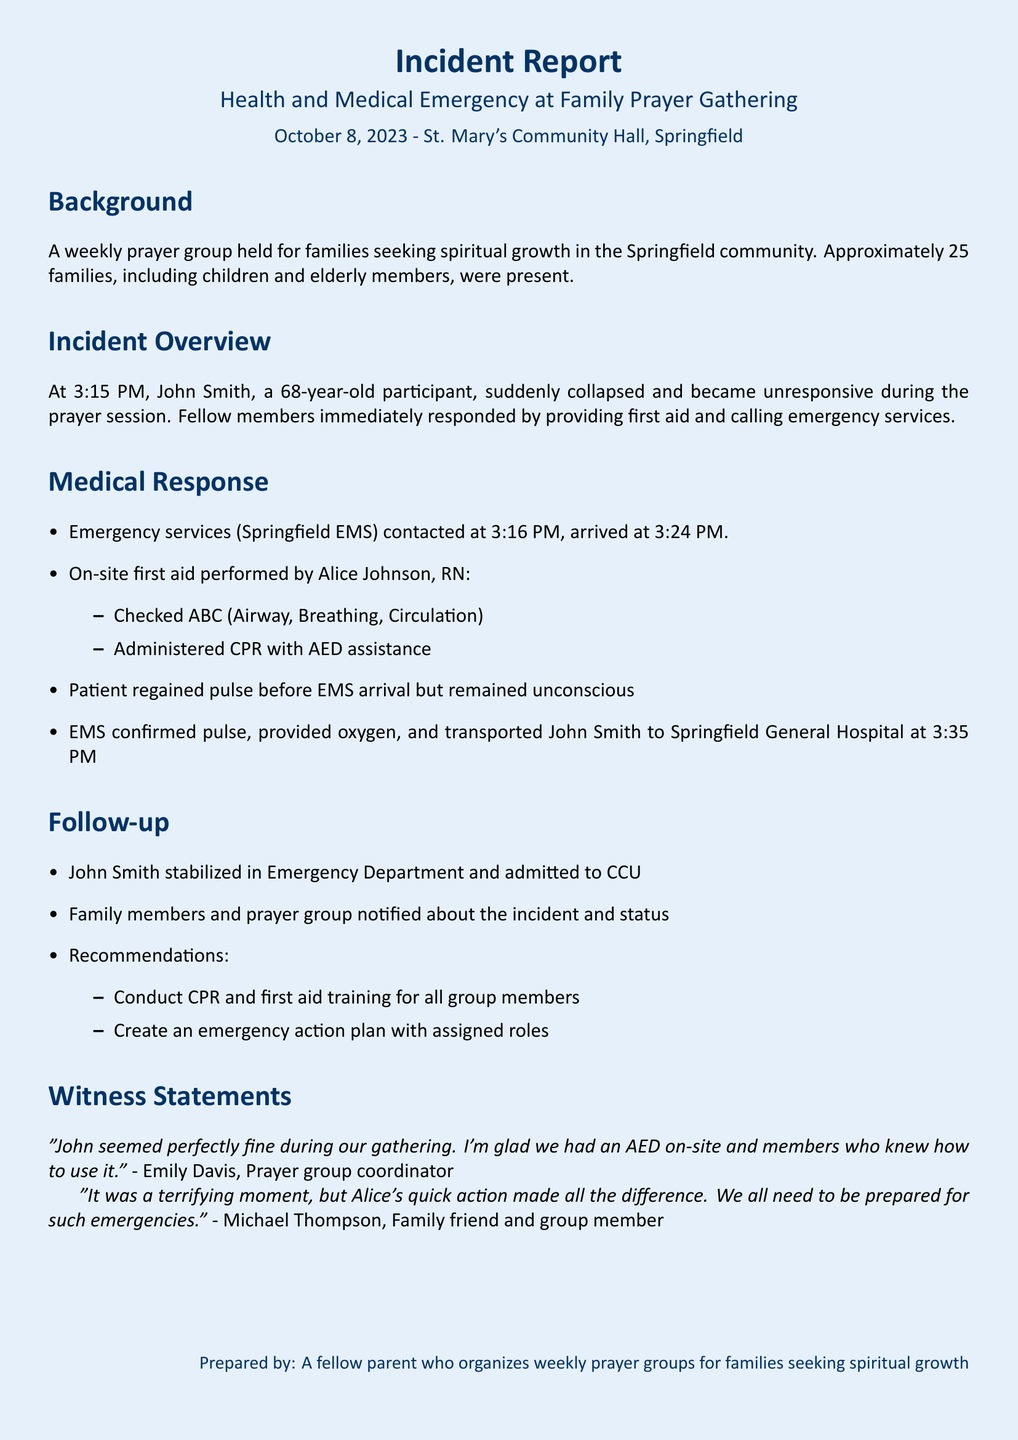What time did the incident occur? The incident occurred at 3:15 PM, as stated in the document.
Answer: 3:15 PM Who performed on-site first aid? The document specifies that Alice Johnson, RN performed the first aid.
Answer: Alice Johnson At what time did EMS arrive? The document states that EMS arrived at 3:24 PM after being contacted at 3:16 PM.
Answer: 3:24 PM What was John Smith's condition when EMS arrived? The document indicates that John Smith regained pulse but remained unconscious when EMS arrived.
Answer: Unconscious What recommendation was made for the prayer group? The document lists conducting CPR and first aid training for all group members as a recommendation.
Answer: CPR and first aid training What was the outcome for John Smith after being transported? The document mentions that John Smith was stabilized in the Emergency Department and admitted to CCU.
Answer: Admitted to CCU How many families were present at the gathering? The document notes that approximately 25 families were present during the gathering.
Answer: 25 families What did Emily Davis say about the incident? Emily Davis mentioned being glad that an AED was on-site and that members knew how to use it.
Answer: AED on-site 